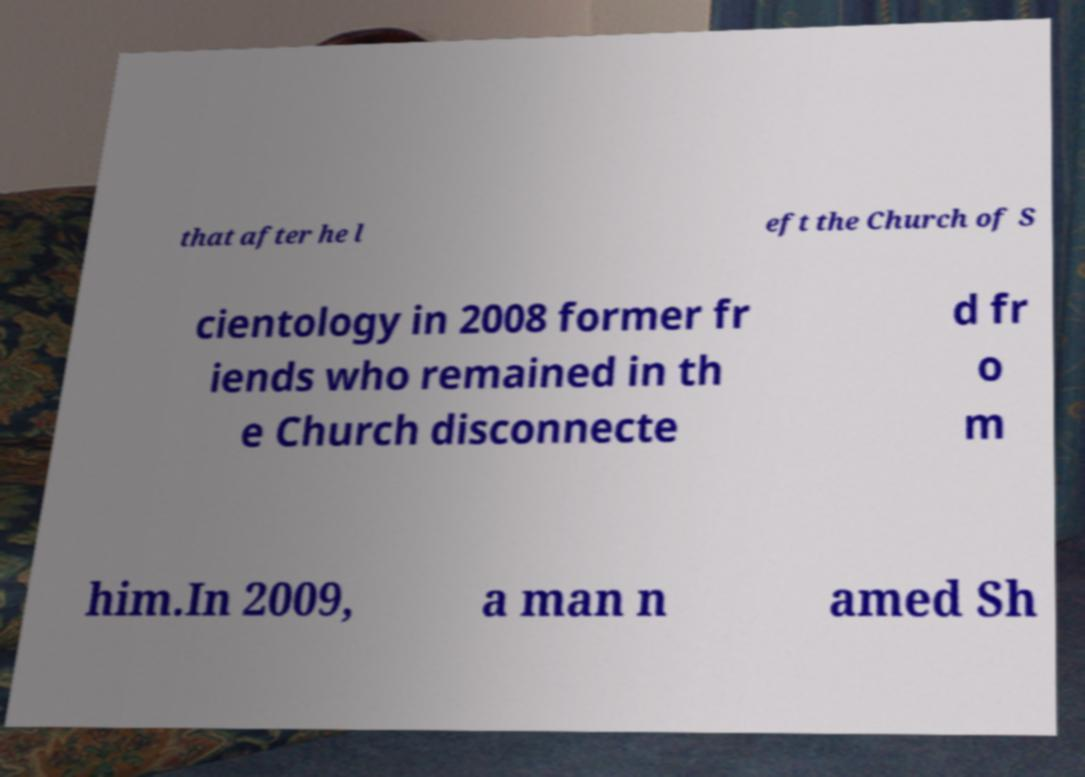What messages or text are displayed in this image? I need them in a readable, typed format. that after he l eft the Church of S cientology in 2008 former fr iends who remained in th e Church disconnecte d fr o m him.In 2009, a man n amed Sh 